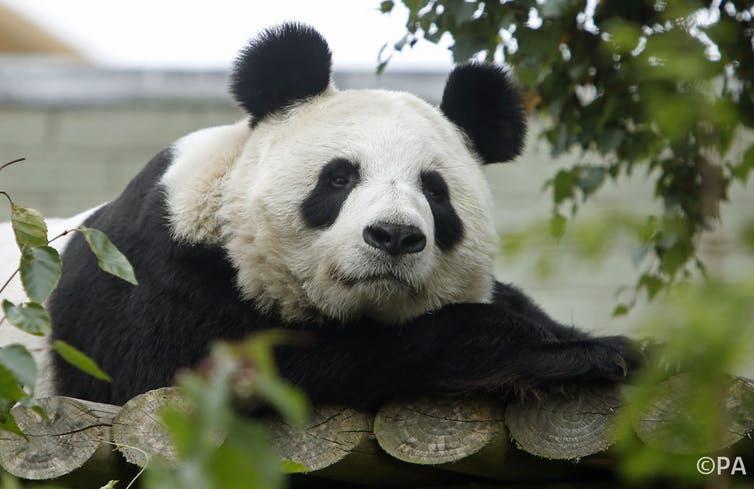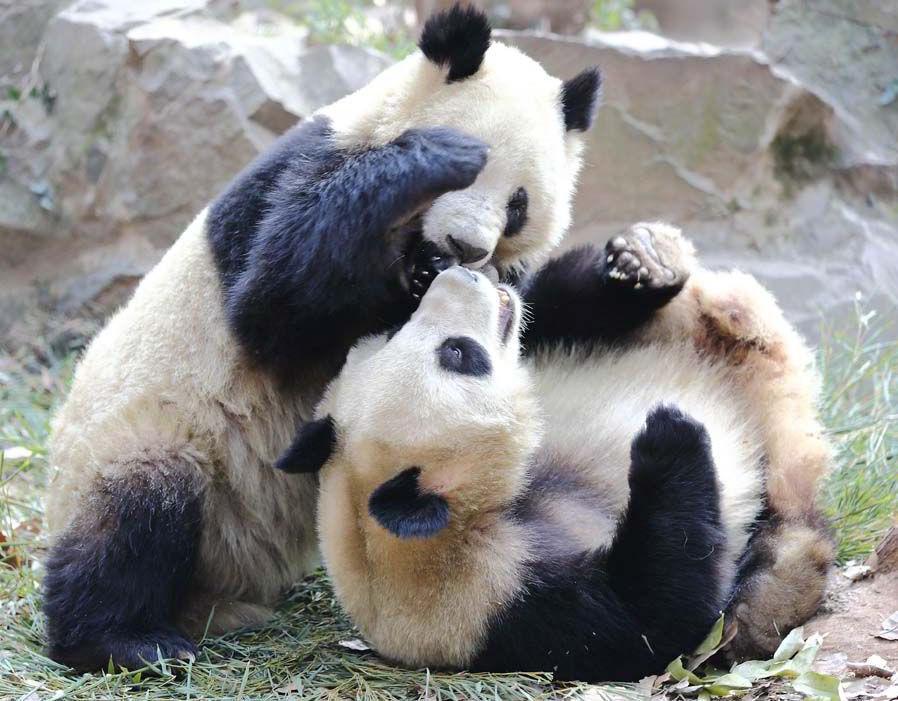The first image is the image on the left, the second image is the image on the right. Given the left and right images, does the statement "there are two pandas in front of a tree trunk" hold true? Answer yes or no. No. The first image is the image on the left, the second image is the image on the right. For the images shown, is this caption "One panda is looking straight ahead." true? Answer yes or no. Yes. 